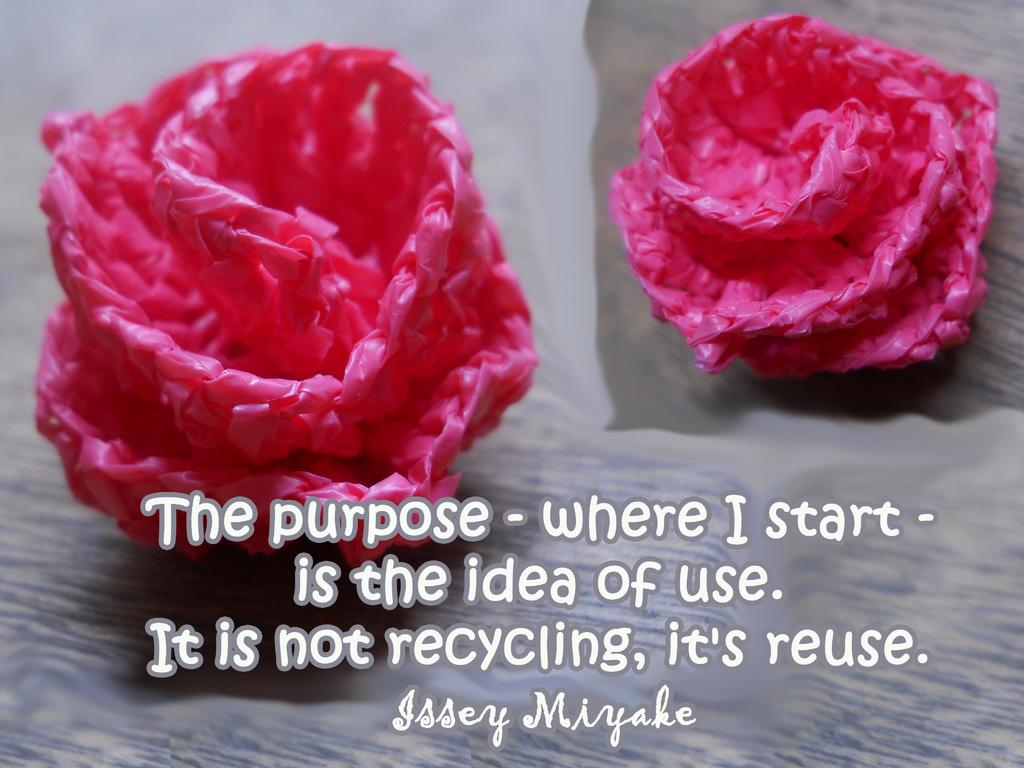What is present on the wall in the image? There is a poster in the image. What decorative items can be seen on the table? There are plastic flowers on both sides of the table. Is there any additional information about the image itself? Yes, there is a watermark at the bottom of the image. What time is depicted on the clock in the image? There is no clock present in the image; it only features a poster, plastic flowers, and a watermark. What type of button can be seen on the shirt of the person in the image? There is no person or shirt present in the image, only a poster and plastic flowers. 